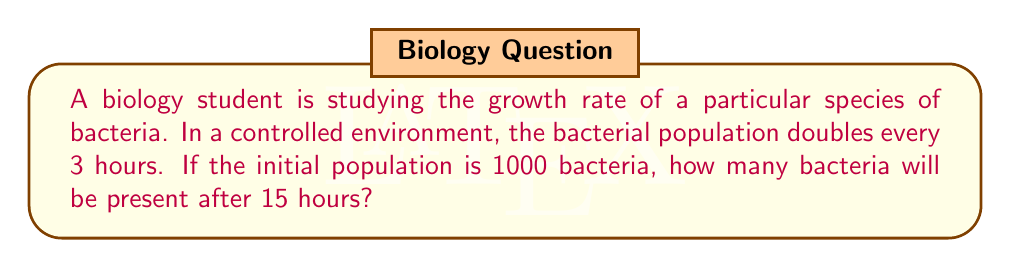Solve this math problem. To solve this problem, we need to use proportions and exponential growth. Let's break it down step-by-step:

1) First, we need to determine how many doubling periods occur in 15 hours:
   $\frac{15 \text{ hours}}{3 \text{ hours per doubling}} = 5$ doubling periods

2) Now, we can set up an exponential growth equation:
   $\text{Final Population} = \text{Initial Population} \times 2^{\text{number of doubling periods}}$

3) Plugging in our values:
   $\text{Final Population} = 1000 \times 2^5$

4) Calculate $2^5$:
   $2^5 = 2 \times 2 \times 2 \times 2 \times 2 = 32$

5) Multiply:
   $\text{Final Population} = 1000 \times 32 = 32,000$

Therefore, after 15 hours, the bacterial population will have grown to 32,000.

We can also express this as a proportion:

$$\frac{\text{Initial Population}}{\text{Final Population}} = \frac{1}{2^{\text{number of doubling periods}}}$$

$$\frac{1000}{\text{Final Population}} = \frac{1}{2^5} = \frac{1}{32}$$

$$\text{Final Population} = 1000 \times 32 = 32,000$$

This proportion method gives us the same result as the exponential growth calculation.
Answer: 32,000 bacteria 